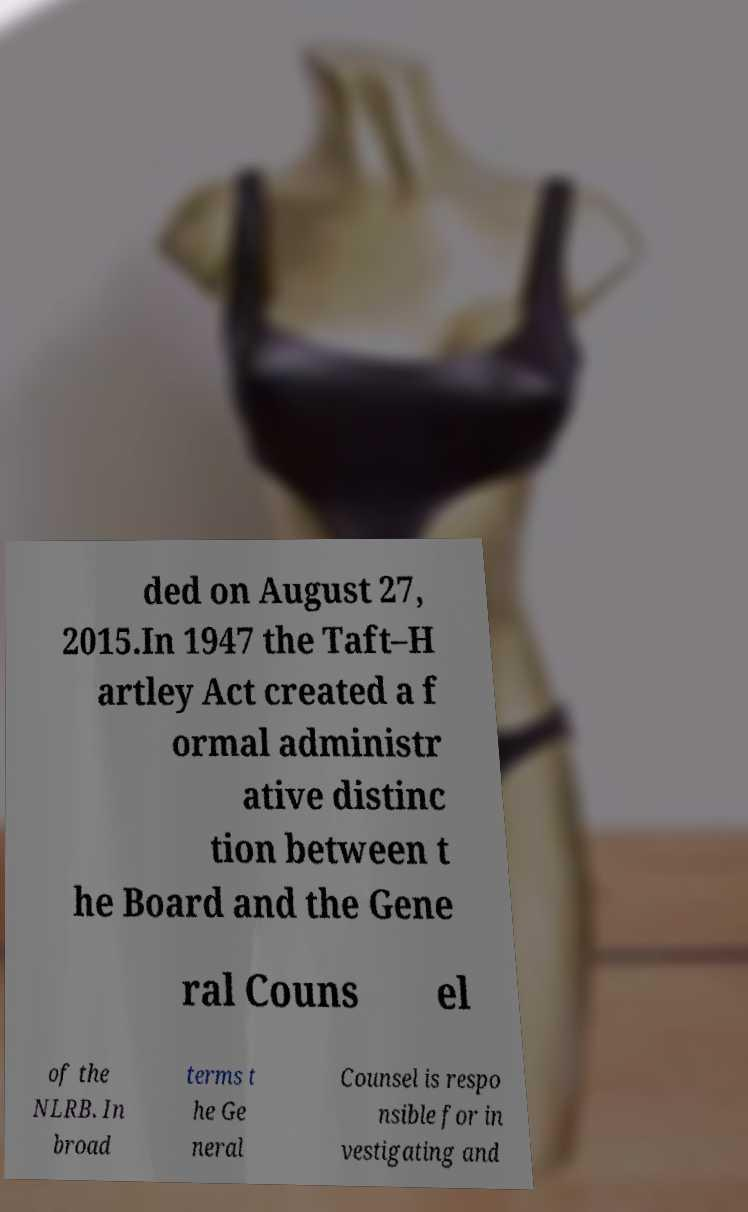What messages or text are displayed in this image? I need them in a readable, typed format. ded on August 27, 2015.In 1947 the Taft–H artley Act created a f ormal administr ative distinc tion between t he Board and the Gene ral Couns el of the NLRB. In broad terms t he Ge neral Counsel is respo nsible for in vestigating and 